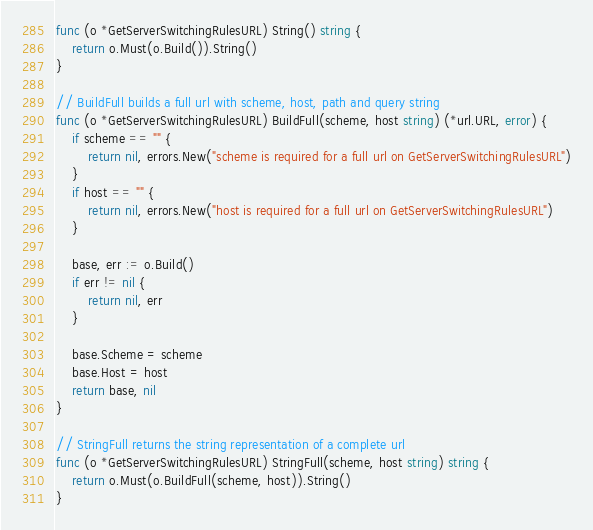Convert code to text. <code><loc_0><loc_0><loc_500><loc_500><_Go_>func (o *GetServerSwitchingRulesURL) String() string {
	return o.Must(o.Build()).String()
}

// BuildFull builds a full url with scheme, host, path and query string
func (o *GetServerSwitchingRulesURL) BuildFull(scheme, host string) (*url.URL, error) {
	if scheme == "" {
		return nil, errors.New("scheme is required for a full url on GetServerSwitchingRulesURL")
	}
	if host == "" {
		return nil, errors.New("host is required for a full url on GetServerSwitchingRulesURL")
	}

	base, err := o.Build()
	if err != nil {
		return nil, err
	}

	base.Scheme = scheme
	base.Host = host
	return base, nil
}

// StringFull returns the string representation of a complete url
func (o *GetServerSwitchingRulesURL) StringFull(scheme, host string) string {
	return o.Must(o.BuildFull(scheme, host)).String()
}
</code> 